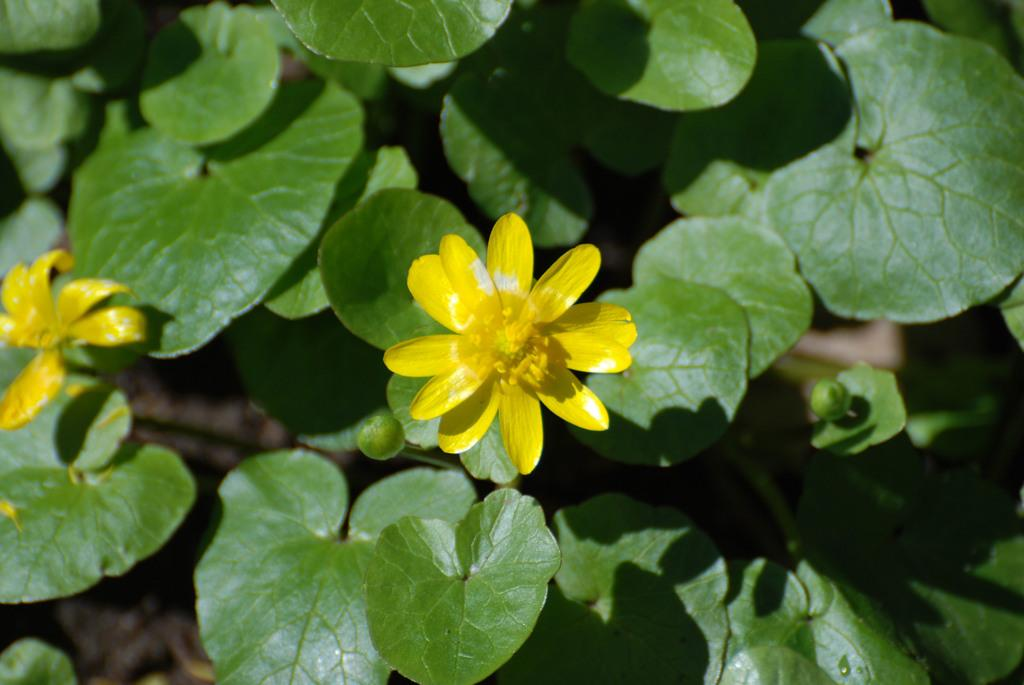What type of vegetation can be seen in the image? There are leaves in the image. How many yellow flowers are present in the image? There are 2 yellow flowers in the image. What is the current temperature in the image? The image does not provide information about the temperature, as it only shows leaves and yellow flowers. 